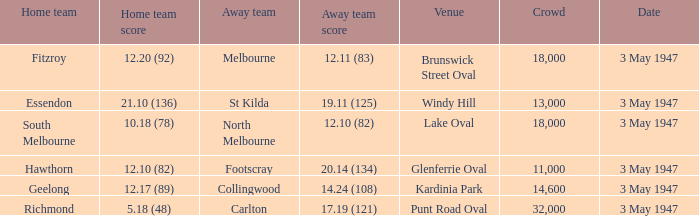Where did the away team register 1 Lake Oval. 